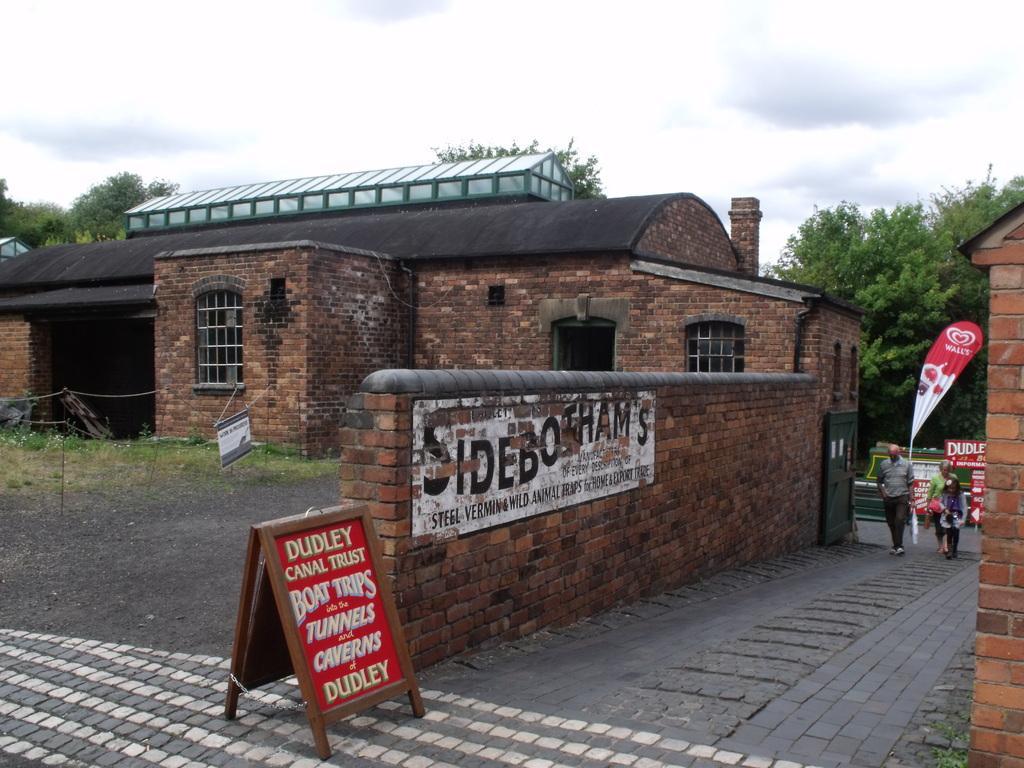Could you give a brief overview of what you see in this image? In this image, we can see a few houses. We can see the ground. We can see the poles with the fence. We can see a board with some text. We can also see some posters. We can see two people. We can see a green colored object. There are a few trees. We can see the sky with clouds. 